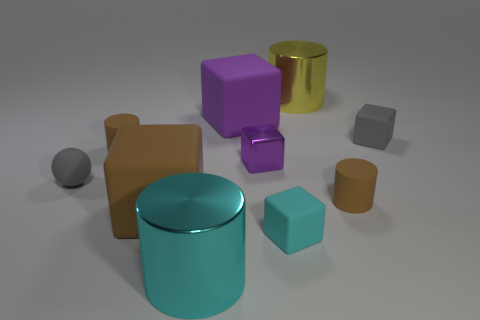Do the large cyan shiny thing and the small brown thing behind the small shiny object have the same shape?
Provide a succinct answer. Yes. Is the number of small brown cylinders left of the cyan cylinder less than the number of big metal cylinders right of the gray block?
Offer a very short reply. No. There is a cyan thing that is the same shape as the tiny purple object; what material is it?
Your answer should be compact. Rubber. There is a big object that is the same material as the big purple cube; what shape is it?
Keep it short and to the point. Cube. What number of small purple objects are the same shape as the small cyan matte thing?
Keep it short and to the point. 1. What shape is the object on the left side of the small brown matte cylinder left of the yellow object?
Keep it short and to the point. Sphere. Is the size of the brown object that is on the right side of the purple matte object the same as the big purple object?
Provide a short and direct response. No. There is a cylinder that is both right of the big cyan shiny thing and behind the tiny gray matte ball; how big is it?
Your answer should be compact. Large. What number of other things are the same size as the yellow metal thing?
Ensure brevity in your answer.  3. What number of brown objects are to the left of the big cylinder that is to the left of the large yellow thing?
Provide a succinct answer. 2. 